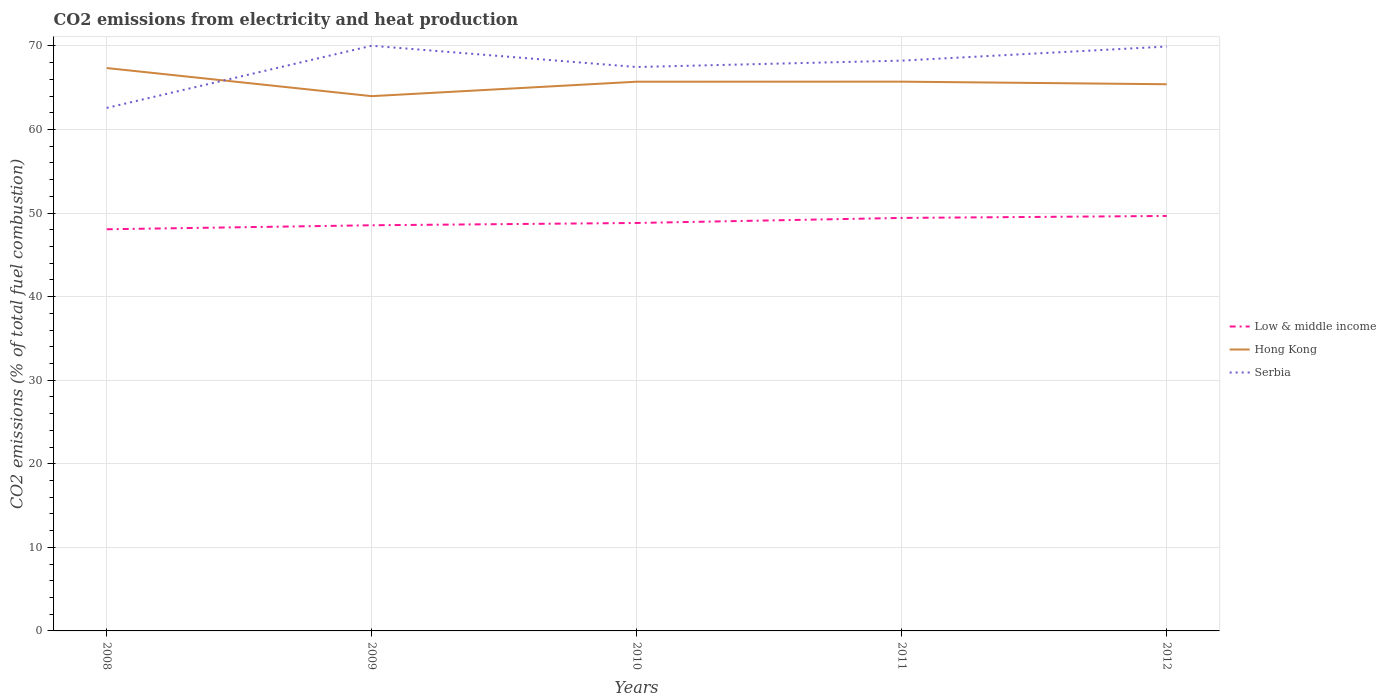How many different coloured lines are there?
Give a very brief answer. 3. Does the line corresponding to Serbia intersect with the line corresponding to Low & middle income?
Your answer should be compact. No. Is the number of lines equal to the number of legend labels?
Ensure brevity in your answer.  Yes. Across all years, what is the maximum amount of CO2 emitted in Hong Kong?
Keep it short and to the point. 63.99. What is the total amount of CO2 emitted in Low & middle income in the graph?
Your response must be concise. -0.84. What is the difference between the highest and the second highest amount of CO2 emitted in Serbia?
Provide a short and direct response. 7.44. How many lines are there?
Offer a terse response. 3. How many years are there in the graph?
Keep it short and to the point. 5. What is the difference between two consecutive major ticks on the Y-axis?
Make the answer very short. 10. Are the values on the major ticks of Y-axis written in scientific E-notation?
Your answer should be very brief. No. Does the graph contain any zero values?
Give a very brief answer. No. Does the graph contain grids?
Give a very brief answer. Yes. Where does the legend appear in the graph?
Your response must be concise. Center right. How many legend labels are there?
Keep it short and to the point. 3. How are the legend labels stacked?
Ensure brevity in your answer.  Vertical. What is the title of the graph?
Give a very brief answer. CO2 emissions from electricity and heat production. Does "Kenya" appear as one of the legend labels in the graph?
Offer a terse response. No. What is the label or title of the X-axis?
Give a very brief answer. Years. What is the label or title of the Y-axis?
Your answer should be compact. CO2 emissions (% of total fuel combustion). What is the CO2 emissions (% of total fuel combustion) in Low & middle income in 2008?
Make the answer very short. 48.06. What is the CO2 emissions (% of total fuel combustion) in Hong Kong in 2008?
Provide a short and direct response. 67.35. What is the CO2 emissions (% of total fuel combustion) of Serbia in 2008?
Offer a very short reply. 62.58. What is the CO2 emissions (% of total fuel combustion) of Low & middle income in 2009?
Provide a succinct answer. 48.54. What is the CO2 emissions (% of total fuel combustion) of Hong Kong in 2009?
Ensure brevity in your answer.  63.99. What is the CO2 emissions (% of total fuel combustion) of Serbia in 2009?
Offer a terse response. 70.02. What is the CO2 emissions (% of total fuel combustion) in Low & middle income in 2010?
Your answer should be very brief. 48.81. What is the CO2 emissions (% of total fuel combustion) of Hong Kong in 2010?
Offer a very short reply. 65.72. What is the CO2 emissions (% of total fuel combustion) in Serbia in 2010?
Offer a terse response. 67.47. What is the CO2 emissions (% of total fuel combustion) of Low & middle income in 2011?
Your answer should be compact. 49.42. What is the CO2 emissions (% of total fuel combustion) of Hong Kong in 2011?
Offer a terse response. 65.72. What is the CO2 emissions (% of total fuel combustion) of Serbia in 2011?
Offer a very short reply. 68.24. What is the CO2 emissions (% of total fuel combustion) in Low & middle income in 2012?
Your answer should be compact. 49.65. What is the CO2 emissions (% of total fuel combustion) of Hong Kong in 2012?
Keep it short and to the point. 65.41. What is the CO2 emissions (% of total fuel combustion) of Serbia in 2012?
Provide a succinct answer. 69.93. Across all years, what is the maximum CO2 emissions (% of total fuel combustion) in Low & middle income?
Offer a very short reply. 49.65. Across all years, what is the maximum CO2 emissions (% of total fuel combustion) in Hong Kong?
Make the answer very short. 67.35. Across all years, what is the maximum CO2 emissions (% of total fuel combustion) of Serbia?
Provide a succinct answer. 70.02. Across all years, what is the minimum CO2 emissions (% of total fuel combustion) of Low & middle income?
Make the answer very short. 48.06. Across all years, what is the minimum CO2 emissions (% of total fuel combustion) of Hong Kong?
Provide a short and direct response. 63.99. Across all years, what is the minimum CO2 emissions (% of total fuel combustion) in Serbia?
Provide a short and direct response. 62.58. What is the total CO2 emissions (% of total fuel combustion) of Low & middle income in the graph?
Your answer should be very brief. 244.49. What is the total CO2 emissions (% of total fuel combustion) of Hong Kong in the graph?
Make the answer very short. 328.2. What is the total CO2 emissions (% of total fuel combustion) of Serbia in the graph?
Offer a terse response. 338.24. What is the difference between the CO2 emissions (% of total fuel combustion) of Low & middle income in 2008 and that in 2009?
Offer a terse response. -0.48. What is the difference between the CO2 emissions (% of total fuel combustion) of Hong Kong in 2008 and that in 2009?
Provide a succinct answer. 3.36. What is the difference between the CO2 emissions (% of total fuel combustion) of Serbia in 2008 and that in 2009?
Provide a short and direct response. -7.44. What is the difference between the CO2 emissions (% of total fuel combustion) in Low & middle income in 2008 and that in 2010?
Offer a terse response. -0.75. What is the difference between the CO2 emissions (% of total fuel combustion) of Hong Kong in 2008 and that in 2010?
Offer a terse response. 1.64. What is the difference between the CO2 emissions (% of total fuel combustion) in Serbia in 2008 and that in 2010?
Provide a short and direct response. -4.89. What is the difference between the CO2 emissions (% of total fuel combustion) in Low & middle income in 2008 and that in 2011?
Make the answer very short. -1.36. What is the difference between the CO2 emissions (% of total fuel combustion) in Hong Kong in 2008 and that in 2011?
Give a very brief answer. 1.63. What is the difference between the CO2 emissions (% of total fuel combustion) in Serbia in 2008 and that in 2011?
Provide a succinct answer. -5.66. What is the difference between the CO2 emissions (% of total fuel combustion) in Low & middle income in 2008 and that in 2012?
Your answer should be compact. -1.59. What is the difference between the CO2 emissions (% of total fuel combustion) in Hong Kong in 2008 and that in 2012?
Give a very brief answer. 1.94. What is the difference between the CO2 emissions (% of total fuel combustion) in Serbia in 2008 and that in 2012?
Keep it short and to the point. -7.35. What is the difference between the CO2 emissions (% of total fuel combustion) of Low & middle income in 2009 and that in 2010?
Ensure brevity in your answer.  -0.28. What is the difference between the CO2 emissions (% of total fuel combustion) in Hong Kong in 2009 and that in 2010?
Keep it short and to the point. -1.73. What is the difference between the CO2 emissions (% of total fuel combustion) in Serbia in 2009 and that in 2010?
Your answer should be very brief. 2.54. What is the difference between the CO2 emissions (% of total fuel combustion) in Low & middle income in 2009 and that in 2011?
Offer a terse response. -0.88. What is the difference between the CO2 emissions (% of total fuel combustion) in Hong Kong in 2009 and that in 2011?
Give a very brief answer. -1.73. What is the difference between the CO2 emissions (% of total fuel combustion) of Serbia in 2009 and that in 2011?
Your answer should be very brief. 1.78. What is the difference between the CO2 emissions (% of total fuel combustion) of Low & middle income in 2009 and that in 2012?
Offer a terse response. -1.11. What is the difference between the CO2 emissions (% of total fuel combustion) in Hong Kong in 2009 and that in 2012?
Offer a terse response. -1.43. What is the difference between the CO2 emissions (% of total fuel combustion) in Serbia in 2009 and that in 2012?
Provide a succinct answer. 0.09. What is the difference between the CO2 emissions (% of total fuel combustion) in Low & middle income in 2010 and that in 2011?
Keep it short and to the point. -0.6. What is the difference between the CO2 emissions (% of total fuel combustion) in Hong Kong in 2010 and that in 2011?
Provide a succinct answer. -0.01. What is the difference between the CO2 emissions (% of total fuel combustion) in Serbia in 2010 and that in 2011?
Keep it short and to the point. -0.77. What is the difference between the CO2 emissions (% of total fuel combustion) of Low & middle income in 2010 and that in 2012?
Provide a short and direct response. -0.84. What is the difference between the CO2 emissions (% of total fuel combustion) in Hong Kong in 2010 and that in 2012?
Provide a succinct answer. 0.3. What is the difference between the CO2 emissions (% of total fuel combustion) in Serbia in 2010 and that in 2012?
Offer a very short reply. -2.45. What is the difference between the CO2 emissions (% of total fuel combustion) of Low & middle income in 2011 and that in 2012?
Provide a short and direct response. -0.23. What is the difference between the CO2 emissions (% of total fuel combustion) of Hong Kong in 2011 and that in 2012?
Your answer should be compact. 0.31. What is the difference between the CO2 emissions (% of total fuel combustion) in Serbia in 2011 and that in 2012?
Your answer should be compact. -1.68. What is the difference between the CO2 emissions (% of total fuel combustion) in Low & middle income in 2008 and the CO2 emissions (% of total fuel combustion) in Hong Kong in 2009?
Offer a very short reply. -15.93. What is the difference between the CO2 emissions (% of total fuel combustion) of Low & middle income in 2008 and the CO2 emissions (% of total fuel combustion) of Serbia in 2009?
Your response must be concise. -21.96. What is the difference between the CO2 emissions (% of total fuel combustion) in Hong Kong in 2008 and the CO2 emissions (% of total fuel combustion) in Serbia in 2009?
Provide a short and direct response. -2.67. What is the difference between the CO2 emissions (% of total fuel combustion) in Low & middle income in 2008 and the CO2 emissions (% of total fuel combustion) in Hong Kong in 2010?
Make the answer very short. -17.66. What is the difference between the CO2 emissions (% of total fuel combustion) of Low & middle income in 2008 and the CO2 emissions (% of total fuel combustion) of Serbia in 2010?
Ensure brevity in your answer.  -19.41. What is the difference between the CO2 emissions (% of total fuel combustion) of Hong Kong in 2008 and the CO2 emissions (% of total fuel combustion) of Serbia in 2010?
Offer a very short reply. -0.12. What is the difference between the CO2 emissions (% of total fuel combustion) of Low & middle income in 2008 and the CO2 emissions (% of total fuel combustion) of Hong Kong in 2011?
Provide a succinct answer. -17.66. What is the difference between the CO2 emissions (% of total fuel combustion) of Low & middle income in 2008 and the CO2 emissions (% of total fuel combustion) of Serbia in 2011?
Your response must be concise. -20.18. What is the difference between the CO2 emissions (% of total fuel combustion) in Hong Kong in 2008 and the CO2 emissions (% of total fuel combustion) in Serbia in 2011?
Give a very brief answer. -0.89. What is the difference between the CO2 emissions (% of total fuel combustion) in Low & middle income in 2008 and the CO2 emissions (% of total fuel combustion) in Hong Kong in 2012?
Make the answer very short. -17.35. What is the difference between the CO2 emissions (% of total fuel combustion) in Low & middle income in 2008 and the CO2 emissions (% of total fuel combustion) in Serbia in 2012?
Your answer should be compact. -21.86. What is the difference between the CO2 emissions (% of total fuel combustion) of Hong Kong in 2008 and the CO2 emissions (% of total fuel combustion) of Serbia in 2012?
Your answer should be compact. -2.57. What is the difference between the CO2 emissions (% of total fuel combustion) of Low & middle income in 2009 and the CO2 emissions (% of total fuel combustion) of Hong Kong in 2010?
Make the answer very short. -17.18. What is the difference between the CO2 emissions (% of total fuel combustion) of Low & middle income in 2009 and the CO2 emissions (% of total fuel combustion) of Serbia in 2010?
Make the answer very short. -18.94. What is the difference between the CO2 emissions (% of total fuel combustion) in Hong Kong in 2009 and the CO2 emissions (% of total fuel combustion) in Serbia in 2010?
Offer a terse response. -3.49. What is the difference between the CO2 emissions (% of total fuel combustion) of Low & middle income in 2009 and the CO2 emissions (% of total fuel combustion) of Hong Kong in 2011?
Make the answer very short. -17.18. What is the difference between the CO2 emissions (% of total fuel combustion) of Low & middle income in 2009 and the CO2 emissions (% of total fuel combustion) of Serbia in 2011?
Offer a terse response. -19.7. What is the difference between the CO2 emissions (% of total fuel combustion) in Hong Kong in 2009 and the CO2 emissions (% of total fuel combustion) in Serbia in 2011?
Make the answer very short. -4.25. What is the difference between the CO2 emissions (% of total fuel combustion) of Low & middle income in 2009 and the CO2 emissions (% of total fuel combustion) of Hong Kong in 2012?
Provide a succinct answer. -16.88. What is the difference between the CO2 emissions (% of total fuel combustion) of Low & middle income in 2009 and the CO2 emissions (% of total fuel combustion) of Serbia in 2012?
Offer a very short reply. -21.39. What is the difference between the CO2 emissions (% of total fuel combustion) in Hong Kong in 2009 and the CO2 emissions (% of total fuel combustion) in Serbia in 2012?
Make the answer very short. -5.94. What is the difference between the CO2 emissions (% of total fuel combustion) in Low & middle income in 2010 and the CO2 emissions (% of total fuel combustion) in Hong Kong in 2011?
Make the answer very short. -16.91. What is the difference between the CO2 emissions (% of total fuel combustion) in Low & middle income in 2010 and the CO2 emissions (% of total fuel combustion) in Serbia in 2011?
Your answer should be very brief. -19.43. What is the difference between the CO2 emissions (% of total fuel combustion) in Hong Kong in 2010 and the CO2 emissions (% of total fuel combustion) in Serbia in 2011?
Your response must be concise. -2.52. What is the difference between the CO2 emissions (% of total fuel combustion) in Low & middle income in 2010 and the CO2 emissions (% of total fuel combustion) in Hong Kong in 2012?
Your answer should be very brief. -16.6. What is the difference between the CO2 emissions (% of total fuel combustion) in Low & middle income in 2010 and the CO2 emissions (% of total fuel combustion) in Serbia in 2012?
Provide a succinct answer. -21.11. What is the difference between the CO2 emissions (% of total fuel combustion) in Hong Kong in 2010 and the CO2 emissions (% of total fuel combustion) in Serbia in 2012?
Offer a terse response. -4.21. What is the difference between the CO2 emissions (% of total fuel combustion) of Low & middle income in 2011 and the CO2 emissions (% of total fuel combustion) of Hong Kong in 2012?
Give a very brief answer. -16. What is the difference between the CO2 emissions (% of total fuel combustion) in Low & middle income in 2011 and the CO2 emissions (% of total fuel combustion) in Serbia in 2012?
Ensure brevity in your answer.  -20.51. What is the difference between the CO2 emissions (% of total fuel combustion) of Hong Kong in 2011 and the CO2 emissions (% of total fuel combustion) of Serbia in 2012?
Offer a very short reply. -4.2. What is the average CO2 emissions (% of total fuel combustion) of Low & middle income per year?
Offer a very short reply. 48.9. What is the average CO2 emissions (% of total fuel combustion) in Hong Kong per year?
Keep it short and to the point. 65.64. What is the average CO2 emissions (% of total fuel combustion) of Serbia per year?
Your answer should be compact. 67.65. In the year 2008, what is the difference between the CO2 emissions (% of total fuel combustion) in Low & middle income and CO2 emissions (% of total fuel combustion) in Hong Kong?
Your answer should be compact. -19.29. In the year 2008, what is the difference between the CO2 emissions (% of total fuel combustion) in Low & middle income and CO2 emissions (% of total fuel combustion) in Serbia?
Make the answer very short. -14.52. In the year 2008, what is the difference between the CO2 emissions (% of total fuel combustion) in Hong Kong and CO2 emissions (% of total fuel combustion) in Serbia?
Offer a very short reply. 4.77. In the year 2009, what is the difference between the CO2 emissions (% of total fuel combustion) of Low & middle income and CO2 emissions (% of total fuel combustion) of Hong Kong?
Provide a succinct answer. -15.45. In the year 2009, what is the difference between the CO2 emissions (% of total fuel combustion) in Low & middle income and CO2 emissions (% of total fuel combustion) in Serbia?
Make the answer very short. -21.48. In the year 2009, what is the difference between the CO2 emissions (% of total fuel combustion) of Hong Kong and CO2 emissions (% of total fuel combustion) of Serbia?
Your answer should be compact. -6.03. In the year 2010, what is the difference between the CO2 emissions (% of total fuel combustion) in Low & middle income and CO2 emissions (% of total fuel combustion) in Hong Kong?
Provide a succinct answer. -16.9. In the year 2010, what is the difference between the CO2 emissions (% of total fuel combustion) in Low & middle income and CO2 emissions (% of total fuel combustion) in Serbia?
Provide a short and direct response. -18.66. In the year 2010, what is the difference between the CO2 emissions (% of total fuel combustion) of Hong Kong and CO2 emissions (% of total fuel combustion) of Serbia?
Your response must be concise. -1.76. In the year 2011, what is the difference between the CO2 emissions (% of total fuel combustion) in Low & middle income and CO2 emissions (% of total fuel combustion) in Hong Kong?
Offer a very short reply. -16.3. In the year 2011, what is the difference between the CO2 emissions (% of total fuel combustion) of Low & middle income and CO2 emissions (% of total fuel combustion) of Serbia?
Make the answer very short. -18.82. In the year 2011, what is the difference between the CO2 emissions (% of total fuel combustion) of Hong Kong and CO2 emissions (% of total fuel combustion) of Serbia?
Provide a succinct answer. -2.52. In the year 2012, what is the difference between the CO2 emissions (% of total fuel combustion) of Low & middle income and CO2 emissions (% of total fuel combustion) of Hong Kong?
Offer a very short reply. -15.76. In the year 2012, what is the difference between the CO2 emissions (% of total fuel combustion) in Low & middle income and CO2 emissions (% of total fuel combustion) in Serbia?
Your answer should be compact. -20.27. In the year 2012, what is the difference between the CO2 emissions (% of total fuel combustion) of Hong Kong and CO2 emissions (% of total fuel combustion) of Serbia?
Provide a short and direct response. -4.51. What is the ratio of the CO2 emissions (% of total fuel combustion) in Low & middle income in 2008 to that in 2009?
Give a very brief answer. 0.99. What is the ratio of the CO2 emissions (% of total fuel combustion) of Hong Kong in 2008 to that in 2009?
Provide a short and direct response. 1.05. What is the ratio of the CO2 emissions (% of total fuel combustion) of Serbia in 2008 to that in 2009?
Provide a short and direct response. 0.89. What is the ratio of the CO2 emissions (% of total fuel combustion) in Low & middle income in 2008 to that in 2010?
Your answer should be very brief. 0.98. What is the ratio of the CO2 emissions (% of total fuel combustion) in Hong Kong in 2008 to that in 2010?
Keep it short and to the point. 1.02. What is the ratio of the CO2 emissions (% of total fuel combustion) of Serbia in 2008 to that in 2010?
Make the answer very short. 0.93. What is the ratio of the CO2 emissions (% of total fuel combustion) in Low & middle income in 2008 to that in 2011?
Your answer should be very brief. 0.97. What is the ratio of the CO2 emissions (% of total fuel combustion) of Hong Kong in 2008 to that in 2011?
Give a very brief answer. 1.02. What is the ratio of the CO2 emissions (% of total fuel combustion) in Serbia in 2008 to that in 2011?
Your response must be concise. 0.92. What is the ratio of the CO2 emissions (% of total fuel combustion) of Low & middle income in 2008 to that in 2012?
Offer a terse response. 0.97. What is the ratio of the CO2 emissions (% of total fuel combustion) of Hong Kong in 2008 to that in 2012?
Your response must be concise. 1.03. What is the ratio of the CO2 emissions (% of total fuel combustion) in Serbia in 2008 to that in 2012?
Ensure brevity in your answer.  0.9. What is the ratio of the CO2 emissions (% of total fuel combustion) in Low & middle income in 2009 to that in 2010?
Make the answer very short. 0.99. What is the ratio of the CO2 emissions (% of total fuel combustion) in Hong Kong in 2009 to that in 2010?
Offer a very short reply. 0.97. What is the ratio of the CO2 emissions (% of total fuel combustion) in Serbia in 2009 to that in 2010?
Give a very brief answer. 1.04. What is the ratio of the CO2 emissions (% of total fuel combustion) of Low & middle income in 2009 to that in 2011?
Provide a succinct answer. 0.98. What is the ratio of the CO2 emissions (% of total fuel combustion) in Hong Kong in 2009 to that in 2011?
Your response must be concise. 0.97. What is the ratio of the CO2 emissions (% of total fuel combustion) of Serbia in 2009 to that in 2011?
Offer a very short reply. 1.03. What is the ratio of the CO2 emissions (% of total fuel combustion) of Low & middle income in 2009 to that in 2012?
Make the answer very short. 0.98. What is the ratio of the CO2 emissions (% of total fuel combustion) in Hong Kong in 2009 to that in 2012?
Provide a succinct answer. 0.98. What is the ratio of the CO2 emissions (% of total fuel combustion) of Serbia in 2009 to that in 2012?
Ensure brevity in your answer.  1. What is the ratio of the CO2 emissions (% of total fuel combustion) in Hong Kong in 2010 to that in 2011?
Your answer should be very brief. 1. What is the ratio of the CO2 emissions (% of total fuel combustion) in Low & middle income in 2010 to that in 2012?
Offer a terse response. 0.98. What is the ratio of the CO2 emissions (% of total fuel combustion) in Hong Kong in 2010 to that in 2012?
Your answer should be compact. 1. What is the ratio of the CO2 emissions (% of total fuel combustion) in Serbia in 2010 to that in 2012?
Keep it short and to the point. 0.96. What is the ratio of the CO2 emissions (% of total fuel combustion) of Hong Kong in 2011 to that in 2012?
Provide a short and direct response. 1. What is the ratio of the CO2 emissions (% of total fuel combustion) in Serbia in 2011 to that in 2012?
Provide a succinct answer. 0.98. What is the difference between the highest and the second highest CO2 emissions (% of total fuel combustion) of Low & middle income?
Your response must be concise. 0.23. What is the difference between the highest and the second highest CO2 emissions (% of total fuel combustion) of Hong Kong?
Your answer should be compact. 1.63. What is the difference between the highest and the second highest CO2 emissions (% of total fuel combustion) in Serbia?
Keep it short and to the point. 0.09. What is the difference between the highest and the lowest CO2 emissions (% of total fuel combustion) in Low & middle income?
Give a very brief answer. 1.59. What is the difference between the highest and the lowest CO2 emissions (% of total fuel combustion) of Hong Kong?
Ensure brevity in your answer.  3.36. What is the difference between the highest and the lowest CO2 emissions (% of total fuel combustion) in Serbia?
Provide a succinct answer. 7.44. 